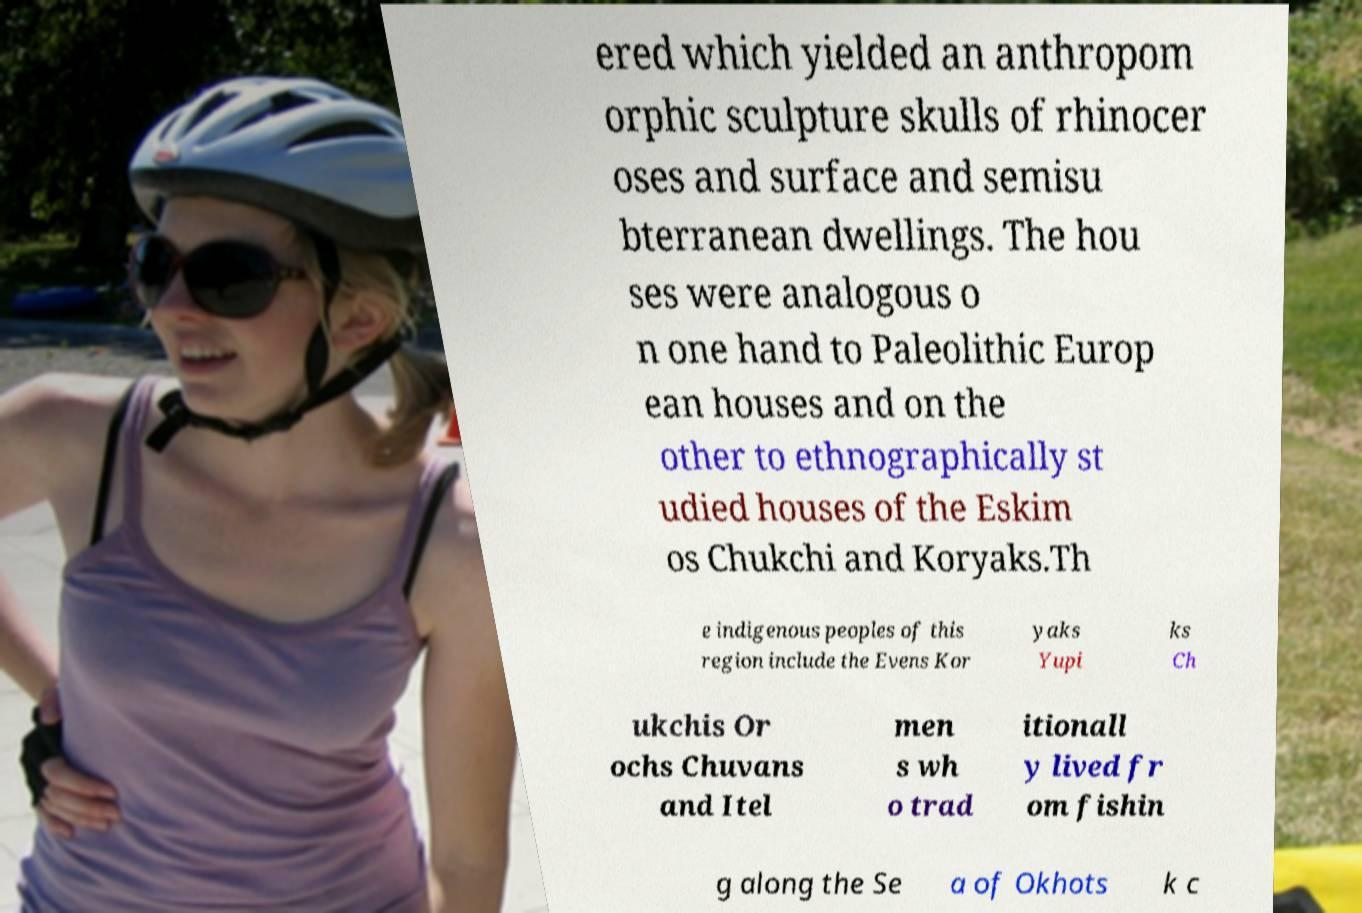There's text embedded in this image that I need extracted. Can you transcribe it verbatim? ered which yielded an anthropom orphic sculpture skulls of rhinocer oses and surface and semisu bterranean dwellings. The hou ses were analogous o n one hand to Paleolithic Europ ean houses and on the other to ethnographically st udied houses of the Eskim os Chukchi and Koryaks.Th e indigenous peoples of this region include the Evens Kor yaks Yupi ks Ch ukchis Or ochs Chuvans and Itel men s wh o trad itionall y lived fr om fishin g along the Se a of Okhots k c 